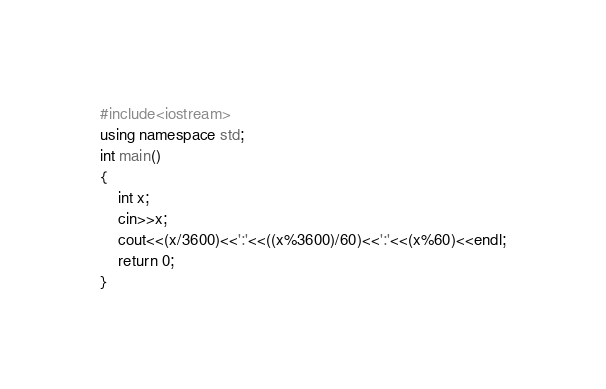<code> <loc_0><loc_0><loc_500><loc_500><_C++_>#include<iostream>
using namespace std;
int main()
{
	int x;
	cin>>x;
	cout<<(x/3600)<<':'<<((x%3600)/60)<<':'<<(x%60)<<endl;
	return 0;
}
</code> 